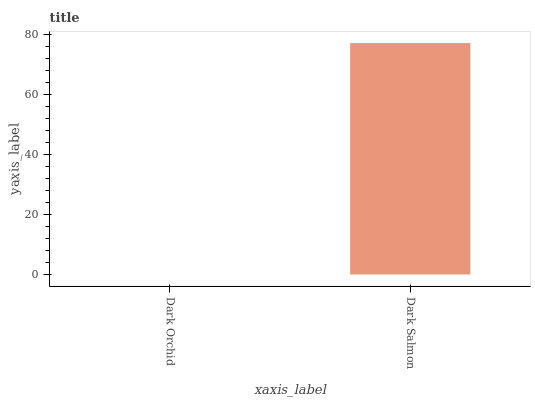Is Dark Orchid the minimum?
Answer yes or no. Yes. Is Dark Salmon the maximum?
Answer yes or no. Yes. Is Dark Salmon the minimum?
Answer yes or no. No. Is Dark Salmon greater than Dark Orchid?
Answer yes or no. Yes. Is Dark Orchid less than Dark Salmon?
Answer yes or no. Yes. Is Dark Orchid greater than Dark Salmon?
Answer yes or no. No. Is Dark Salmon less than Dark Orchid?
Answer yes or no. No. Is Dark Salmon the high median?
Answer yes or no. Yes. Is Dark Orchid the low median?
Answer yes or no. Yes. Is Dark Orchid the high median?
Answer yes or no. No. Is Dark Salmon the low median?
Answer yes or no. No. 